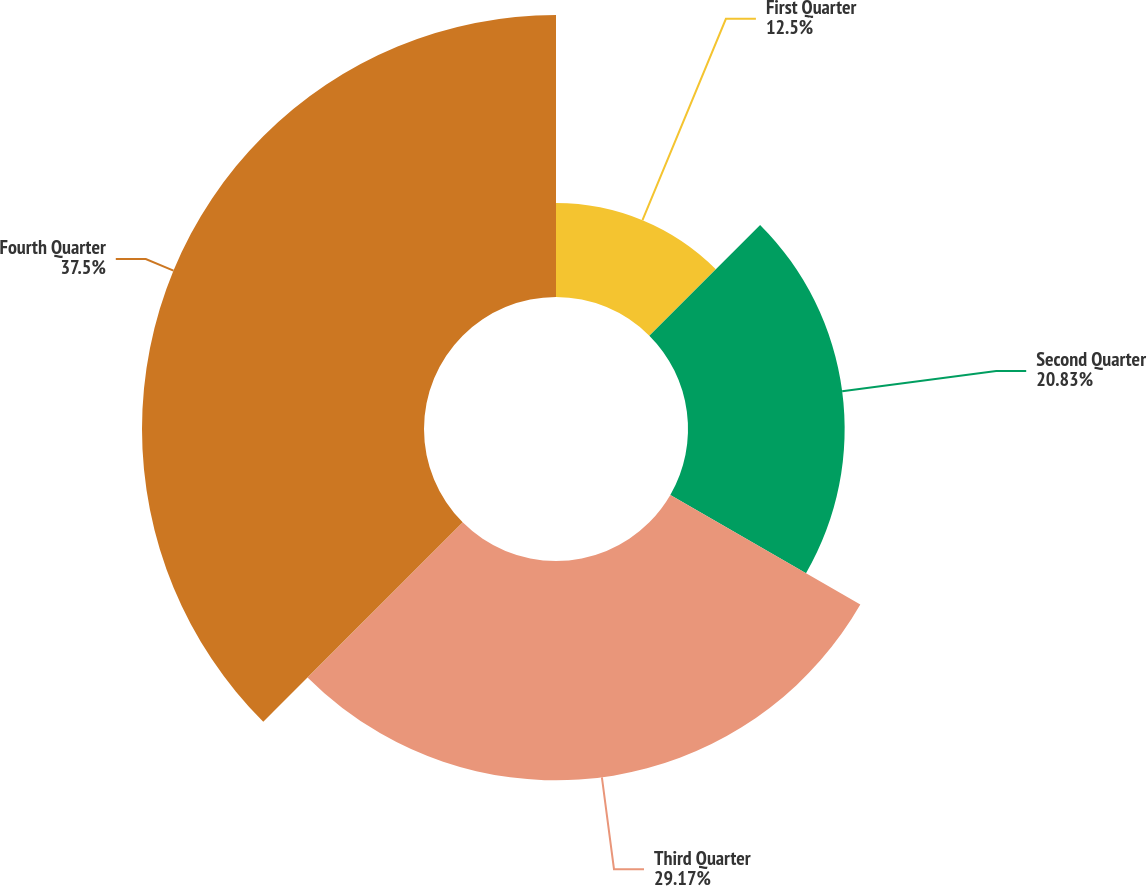Convert chart. <chart><loc_0><loc_0><loc_500><loc_500><pie_chart><fcel>First Quarter<fcel>Second Quarter<fcel>Third Quarter<fcel>Fourth Quarter<nl><fcel>12.5%<fcel>20.83%<fcel>29.17%<fcel>37.5%<nl></chart> 